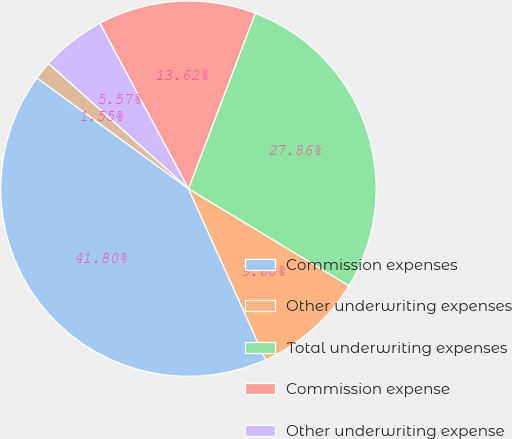Convert chart. <chart><loc_0><loc_0><loc_500><loc_500><pie_chart><fcel>Commission expenses<fcel>Other underwriting expenses<fcel>Total underwriting expenses<fcel>Commission expense<fcel>Other underwriting expense<fcel>Total underwriting expense<nl><fcel>41.8%<fcel>9.6%<fcel>27.86%<fcel>13.62%<fcel>5.57%<fcel>1.55%<nl></chart> 